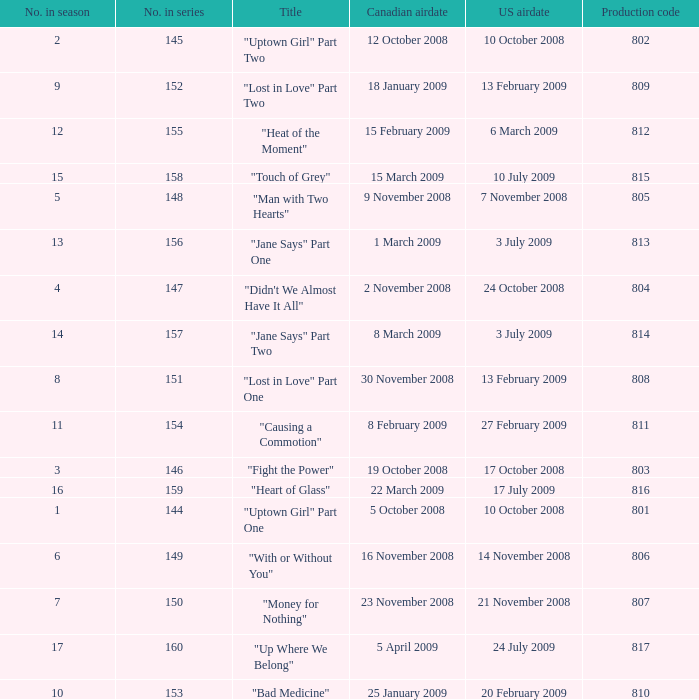How many U.S. air dates were from an episode in Season 4? 1.0. 